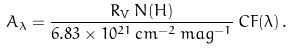Convert formula to latex. <formula><loc_0><loc_0><loc_500><loc_500>A _ { \lambda } = \frac { R _ { \mathrm V } \, N ( H ) } { 6 . 8 3 \times 1 0 ^ { 2 1 } \, c m ^ { - 2 } \, m a g ^ { - 1 } } \, C F ( \lambda ) \, .</formula> 